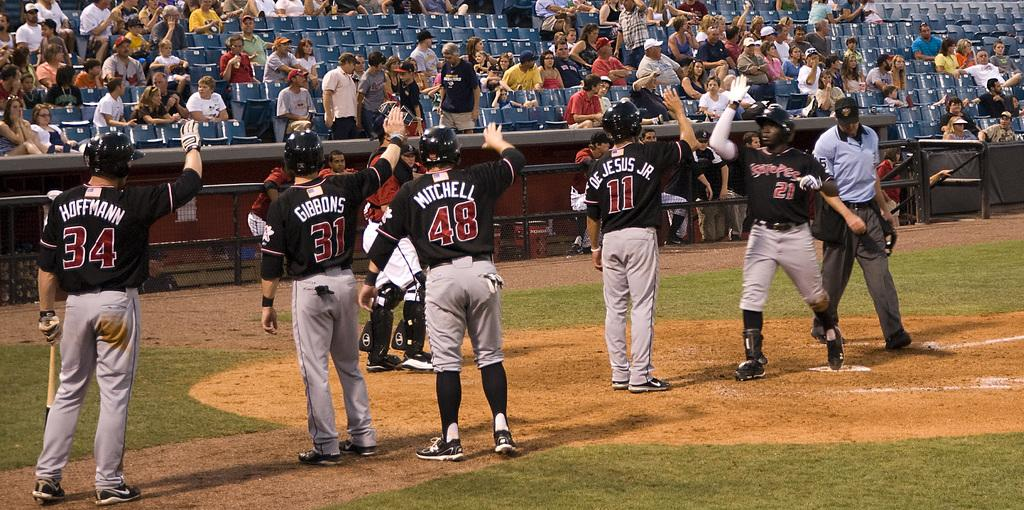<image>
Offer a succinct explanation of the picture presented. Hoffman will be the last player that number 21 high fives. 